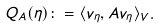<formula> <loc_0><loc_0><loc_500><loc_500>Q _ { A } ( \eta ) \colon = \langle v _ { \eta } , A v _ { \eta } \rangle _ { V } .</formula> 